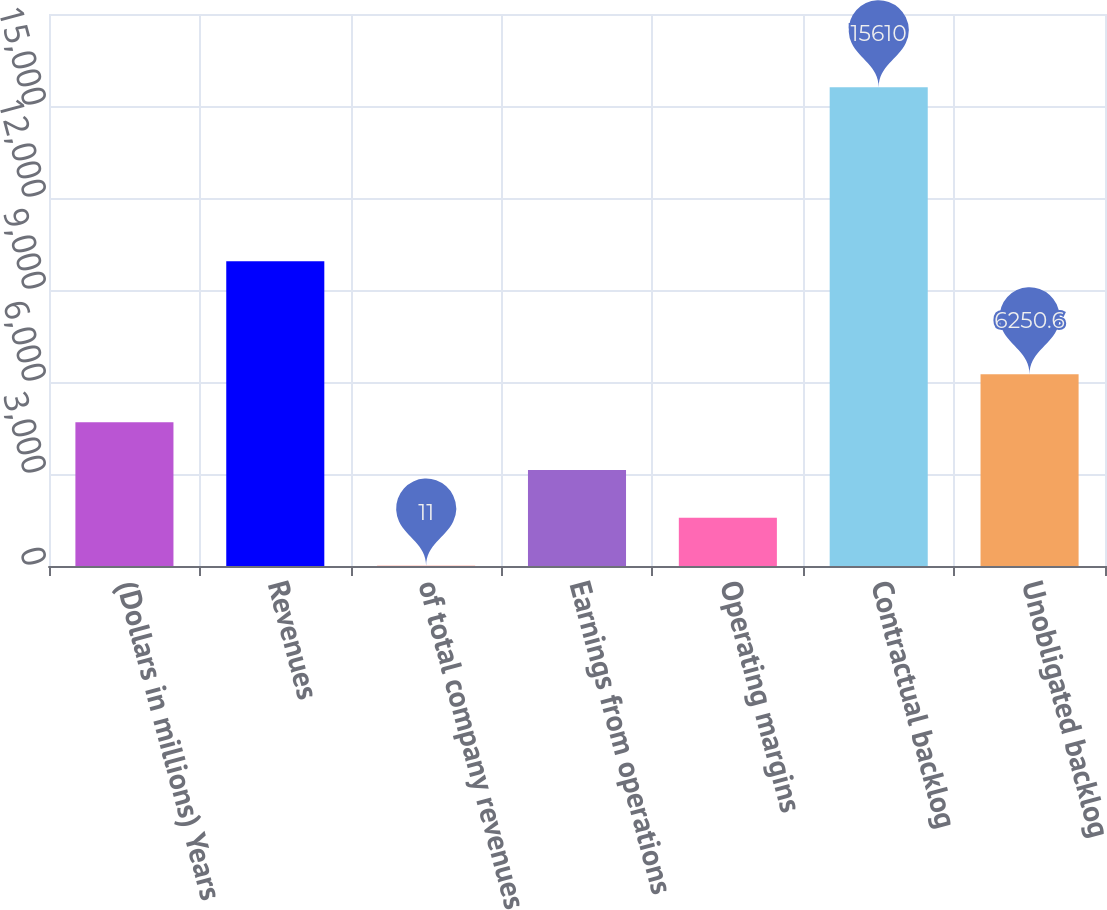<chart> <loc_0><loc_0><loc_500><loc_500><bar_chart><fcel>(Dollars in millions) Years<fcel>Revenues<fcel>of total company revenues<fcel>Earnings from operations<fcel>Operating margins<fcel>Contractual backlog<fcel>Unobligated backlog<nl><fcel>4690.7<fcel>9937<fcel>11<fcel>3130.8<fcel>1570.9<fcel>15610<fcel>6250.6<nl></chart> 